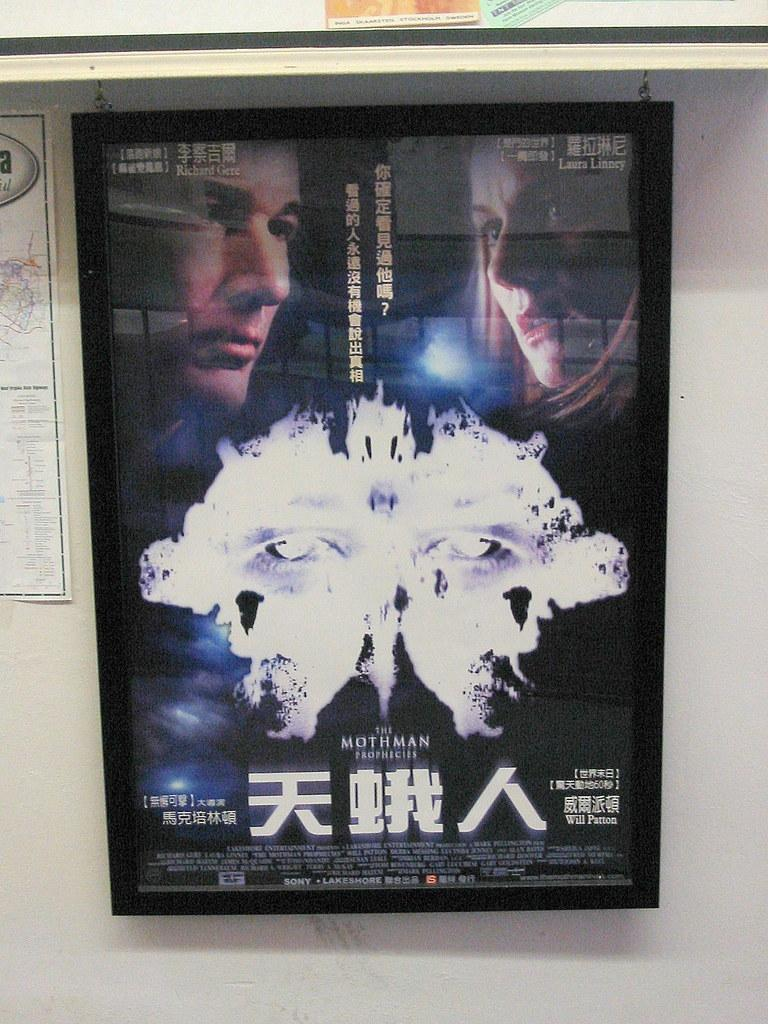<image>
Share a concise interpretation of the image provided. A poster for the Mothman movie in a glass case. 